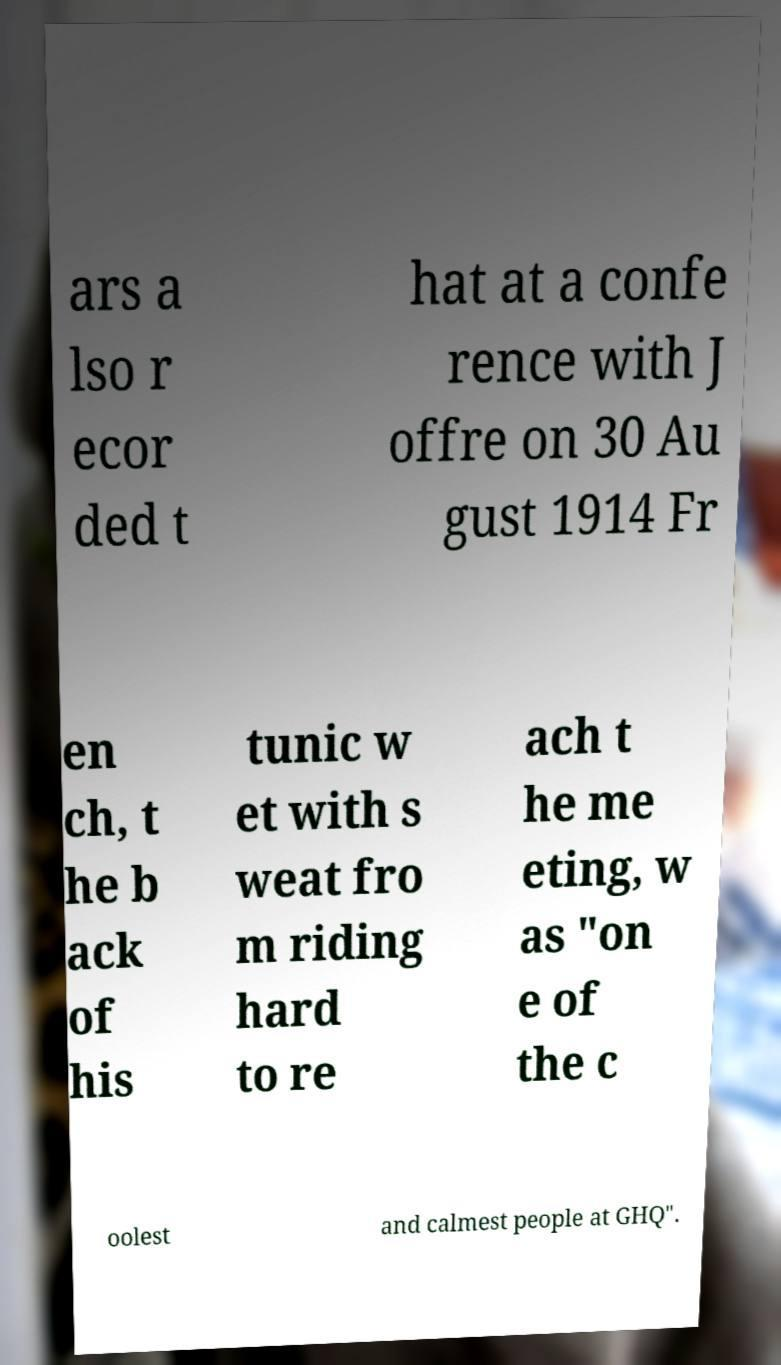I need the written content from this picture converted into text. Can you do that? ars a lso r ecor ded t hat at a confe rence with J offre on 30 Au gust 1914 Fr en ch, t he b ack of his tunic w et with s weat fro m riding hard to re ach t he me eting, w as "on e of the c oolest and calmest people at GHQ". 